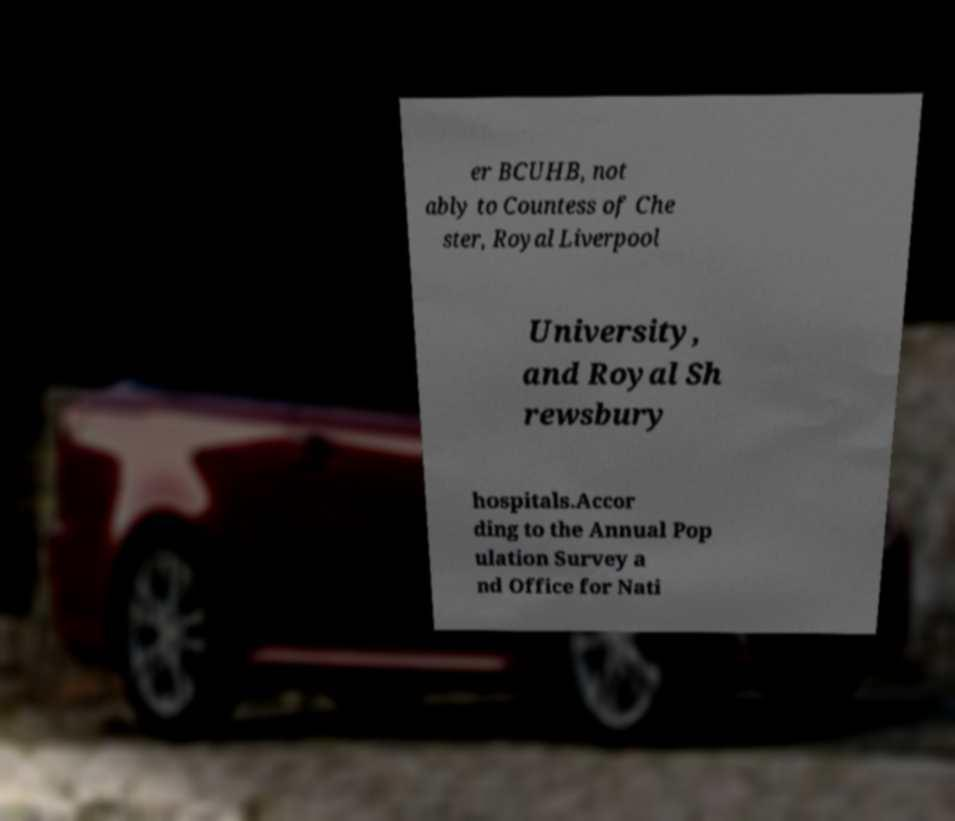Can you accurately transcribe the text from the provided image for me? er BCUHB, not ably to Countess of Che ster, Royal Liverpool University, and Royal Sh rewsbury hospitals.Accor ding to the Annual Pop ulation Survey a nd Office for Nati 